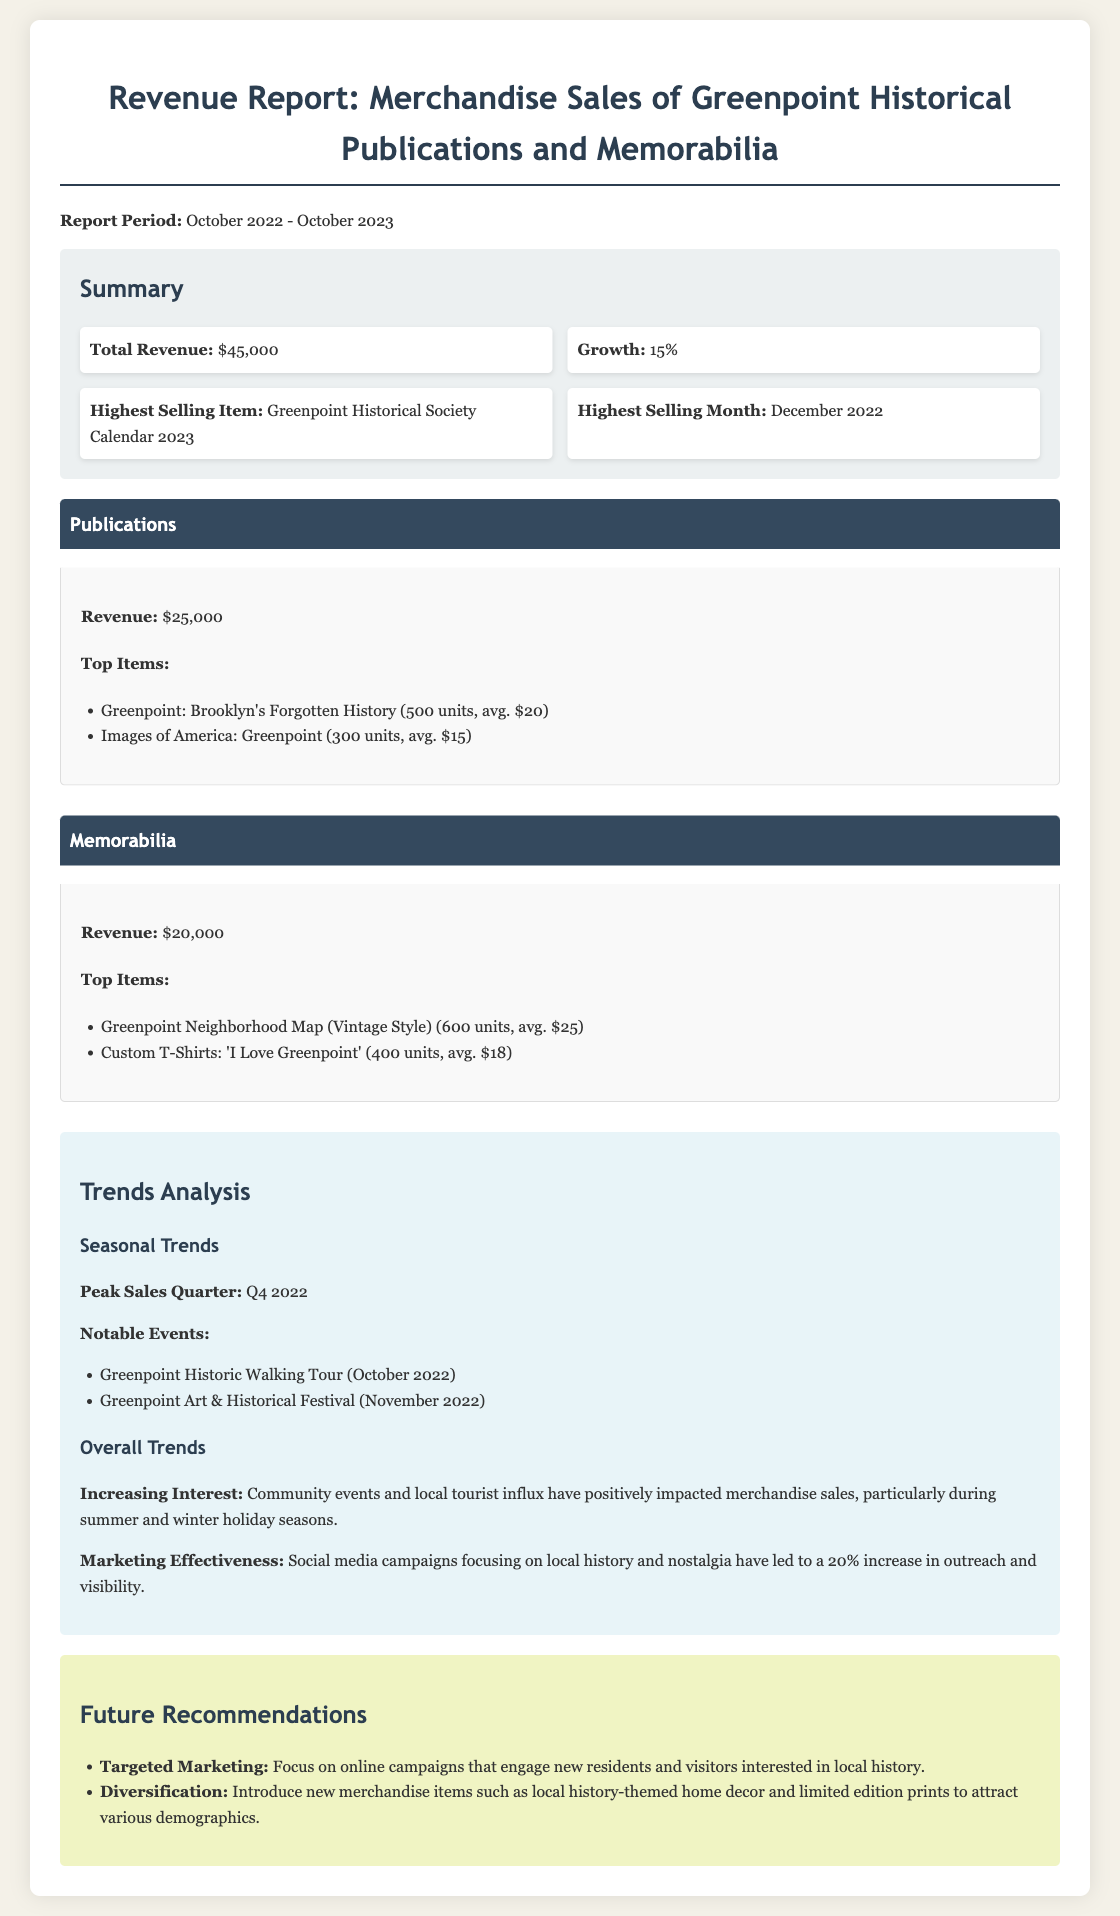What is the total revenue? The total revenue is mentioned in the summary section of the document as $45,000.
Answer: $45,000 What is the growth percentage? The growth percentage is indicated in the summary section of the report, which states a growth of 15%.
Answer: 15% What was the highest selling item? The document lists the highest selling item in the summary section as the Greenpoint Historical Society Calendar 2023.
Answer: Greenpoint Historical Society Calendar 2023 When was the highest selling month? The summary section identifies December 2022 as the highest selling month.
Answer: December 2022 What is the revenue from publications? The revenue generated from publications is stated in the category section as $25,000.
Answer: $25,000 How many units of the book "Greenpoint: Brooklyn's Forgotten History" were sold? The category content specifies that 500 units of "Greenpoint: Brooklyn's Forgotten History" were sold.
Answer: 500 units Which quarter had peak sales? The document mentions that Q4 2022 was the peak sales quarter.
Answer: Q4 2022 What marketing strategy led to a 20% increase in outreach? The trend analysis notes that social media campaigns focusing on local history and nostalgia contributed to the increase in outreach.
Answer: Social media campaigns What are future recommendations for marketing? The recommendations section suggests focusing on online campaigns that engage new residents and visitors interested in local history.
Answer: Targeted Marketing 